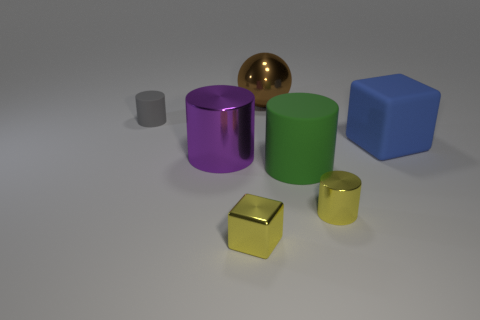Subtract 1 cylinders. How many cylinders are left? 3 Add 3 gray objects. How many objects exist? 10 Subtract all cylinders. How many objects are left? 3 Add 3 big blue objects. How many big blue objects are left? 4 Add 2 large brown matte objects. How many large brown matte objects exist? 2 Subtract 0 cyan cylinders. How many objects are left? 7 Subtract all brown matte cylinders. Subtract all large purple shiny things. How many objects are left? 6 